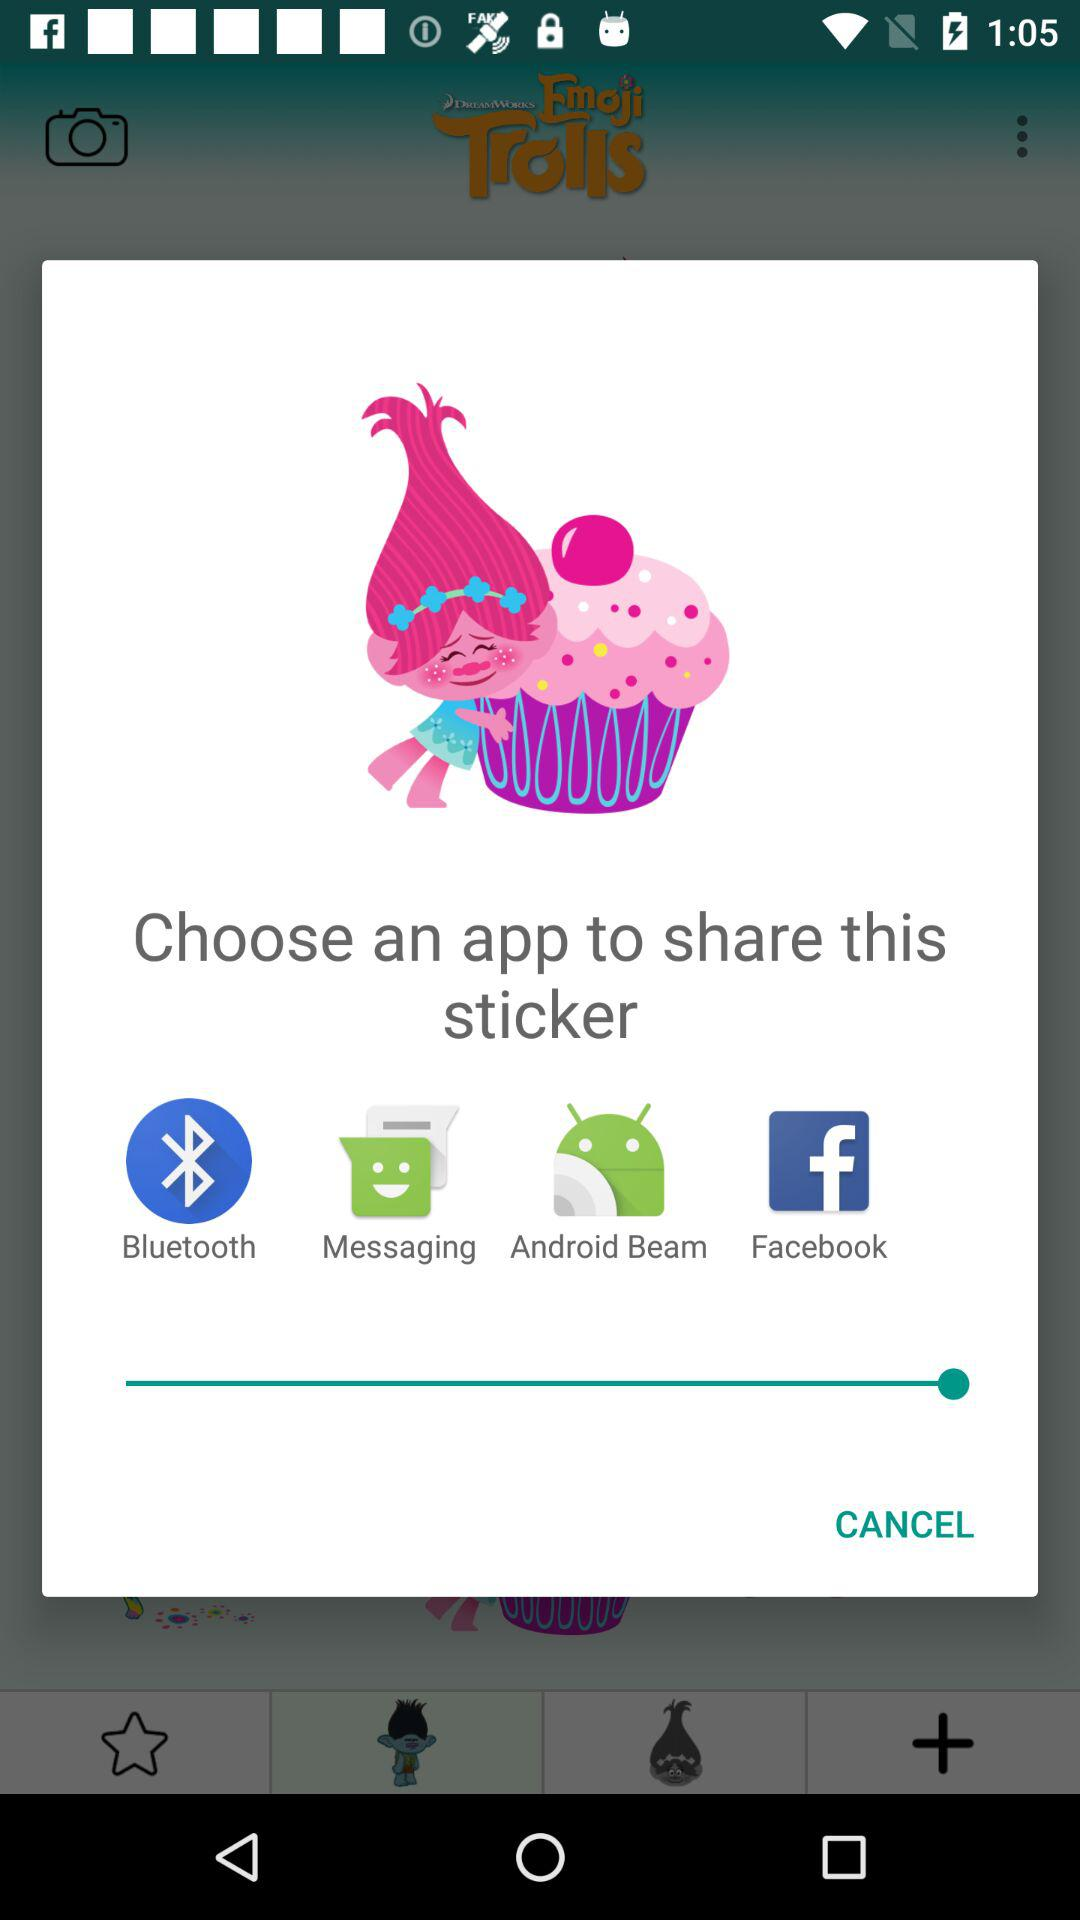How many apps are available to share the sticker?
Answer the question using a single word or phrase. 4 